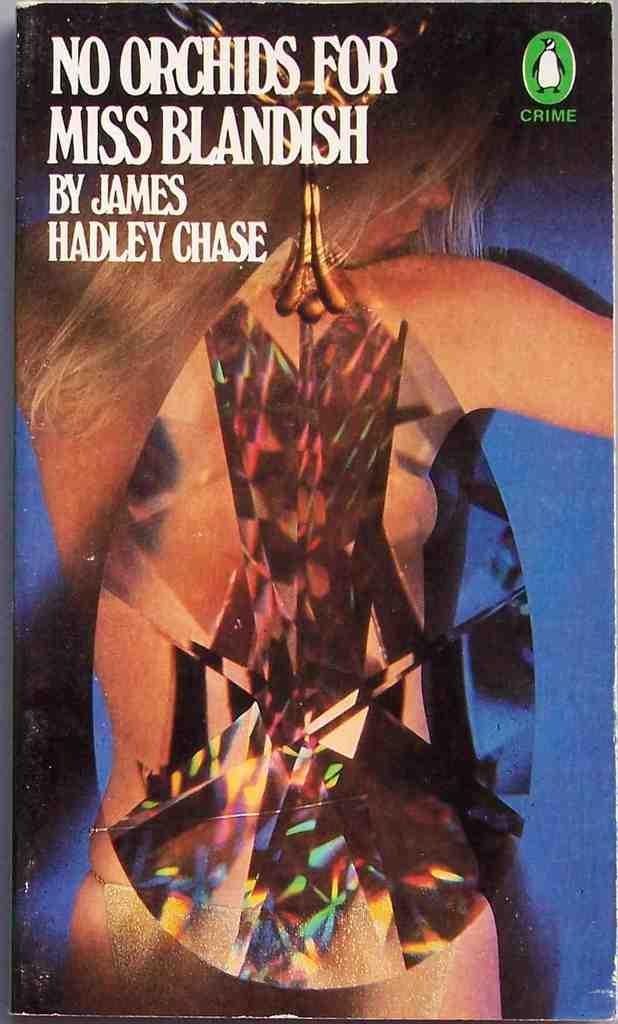What is depicted on the poster in the picture? There is a poster of a woman in the picture. What can be seen at the top of the picture? There is text written at the top of the picture. What color is the background of the picture? The background color is blue. Can you tell me how many cattle are visible in the picture? There are no cattle present in the picture; it features a poster of a woman and text. Is the woman in the poster in motion? The image of the woman on the poster is static, so there is no motion depicted. 